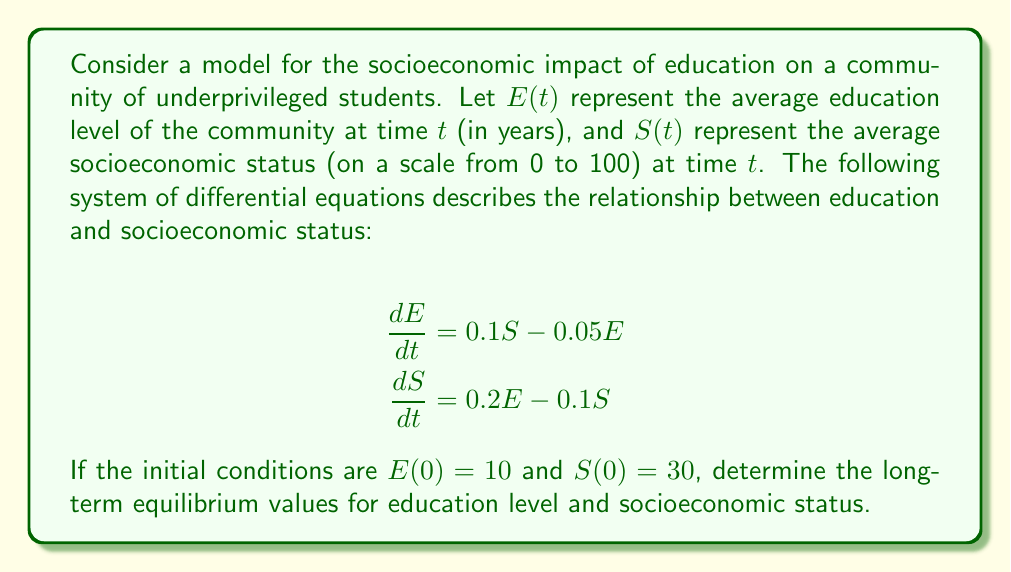Solve this math problem. To find the long-term equilibrium values, we need to solve for the steady-state solution where $\frac{dE}{dt} = 0$ and $\frac{dS}{dt} = 0$.

Step 1: Set both equations to zero:
$$\begin{align*}
0 &= 0.1S - 0.05E \\
0 &= 0.2E - 0.1S
\end{align*}$$

Step 2: Solve the first equation for $S$ in terms of $E$:
$$0.1S - 0.05E = 0$$
$$0.1S = 0.05E$$
$$S = 0.5E$$

Step 3: Substitute this expression for $S$ into the second equation:
$$0 = 0.2E - 0.1(0.5E)$$
$$0 = 0.2E - 0.05E$$
$$0 = 0.15E$$

Step 4: Solve for $E$:
$$E = 0$$

Step 5: Substitute $E = 0$ back into the equation $S = 0.5E$ to find $S$:
$$S = 0.5(0) = 0$$

Therefore, the long-term equilibrium values are $E = 0$ and $S = 0$. However, this result is not realistic in the context of education and socioeconomic status.

Step 6: Interpret the result:
The model suggests that without external interventions or additional factors, the system tends towards a trivial equilibrium where both education level and socioeconomic status decrease to zero. This highlights the importance of continuous support and investment in education to maintain and improve socioeconomic conditions in underprivileged communities.
Answer: $E = 0$, $S = 0$ 